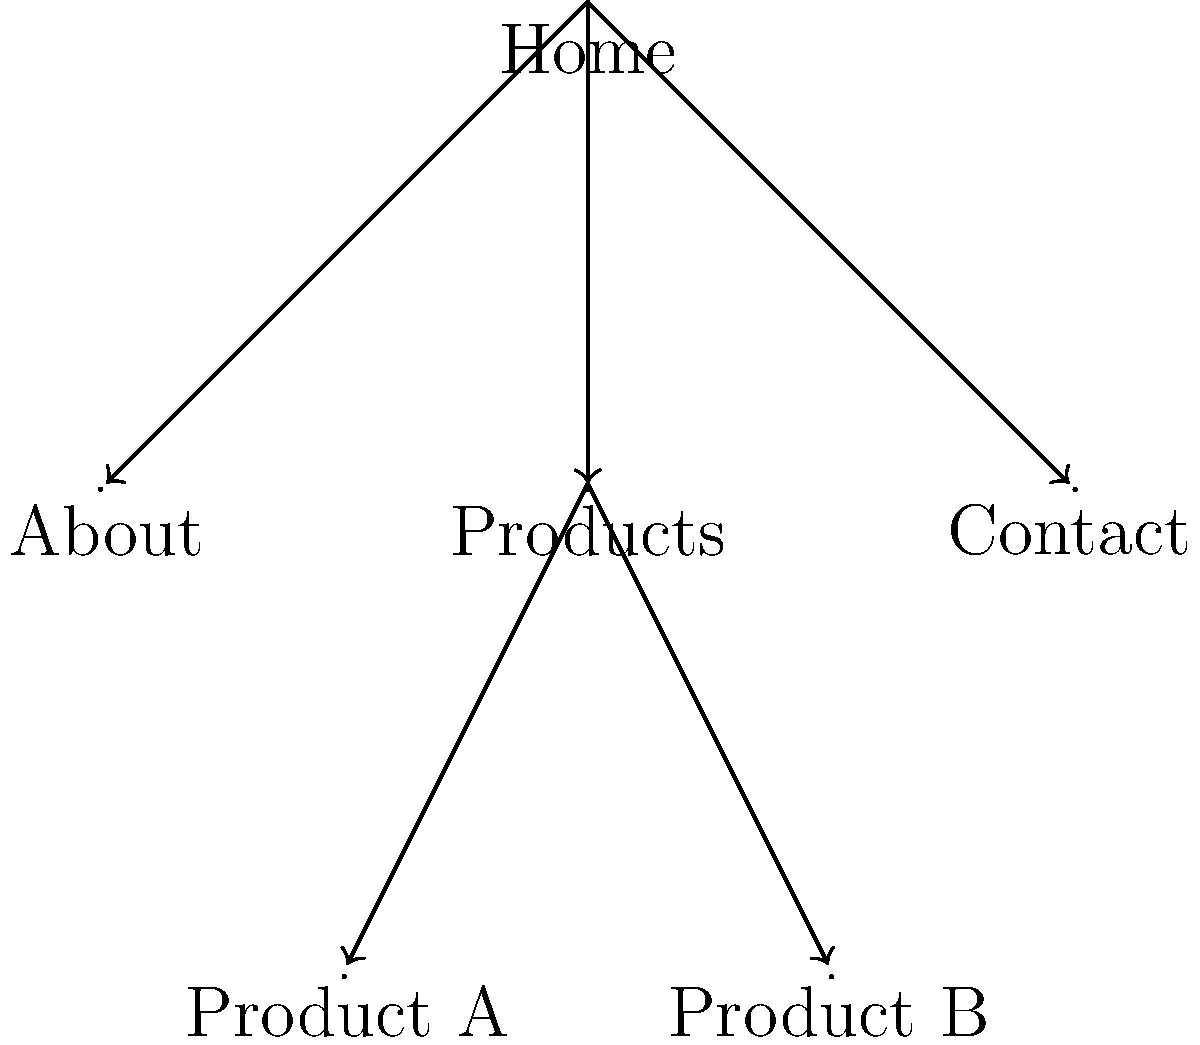Based on the sitemap diagram, which improvement would most effectively enhance the website's navigation for users looking for specific product information? To improve the website's navigation using the sitemap diagram, we need to analyze the current structure and identify potential enhancements:

1. The current structure shows a home page with three main sections: About, Products, and Contact.
2. The Products page leads to two specific product pages: Product A and Product B.
3. Users need to navigate through two levels (Home > Products > Specific Product) to reach product information.

To enhance navigation for users seeking specific product information, we can consider the following improvements:

1. Add direct links from the home page to specific product pages, reducing the number of clicks required.
2. Implement a dropdown menu for the Products section on the main navigation bar, allowing users to access specific product pages directly.
3. Include a search function on the home page for quick access to product information.
4. Create a "Featured Products" section on the home page with links to popular items.

Among these options, implementing a dropdown menu for the Products section would be the most effective improvement. This solution:

a) Maintains the current site structure
b) Reduces the number of clicks needed to reach product pages
c) Improves visibility of available products
d) Enhances user experience without major redesign

Therefore, the most effective improvement would be to add a dropdown menu for the Products section in the main navigation.
Answer: Add a dropdown menu for the Products section 